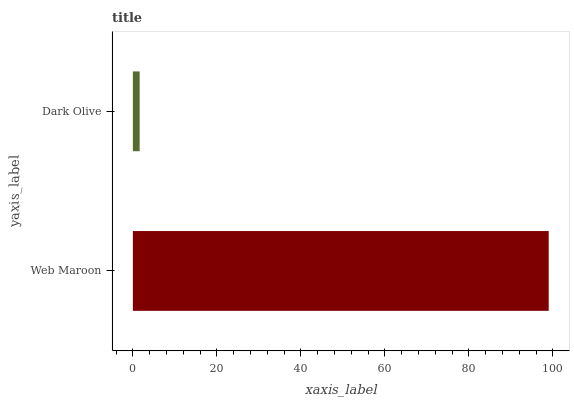Is Dark Olive the minimum?
Answer yes or no. Yes. Is Web Maroon the maximum?
Answer yes or no. Yes. Is Dark Olive the maximum?
Answer yes or no. No. Is Web Maroon greater than Dark Olive?
Answer yes or no. Yes. Is Dark Olive less than Web Maroon?
Answer yes or no. Yes. Is Dark Olive greater than Web Maroon?
Answer yes or no. No. Is Web Maroon less than Dark Olive?
Answer yes or no. No. Is Web Maroon the high median?
Answer yes or no. Yes. Is Dark Olive the low median?
Answer yes or no. Yes. Is Dark Olive the high median?
Answer yes or no. No. Is Web Maroon the low median?
Answer yes or no. No. 